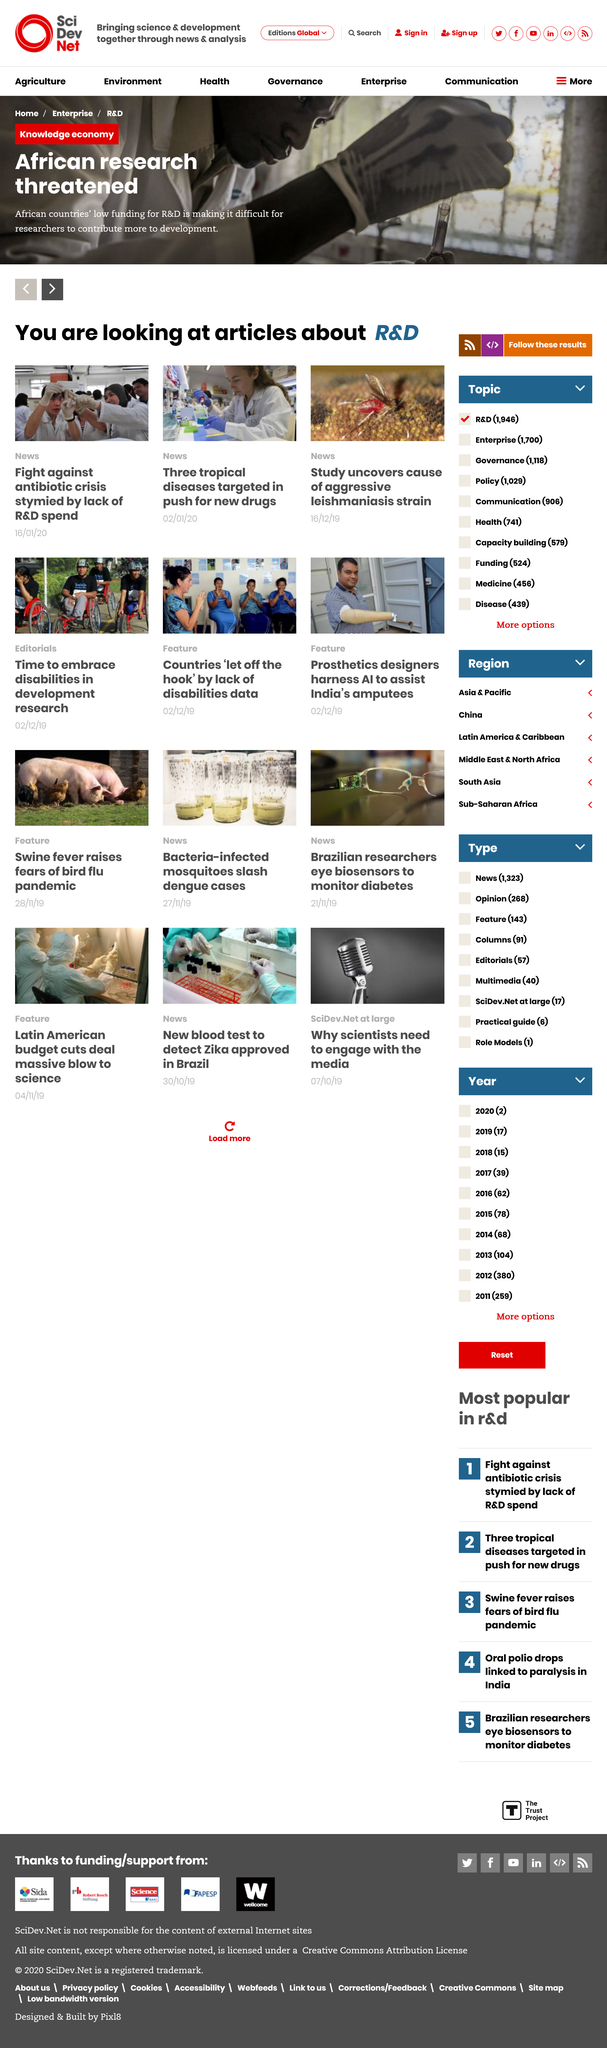Give some essential details in this illustration. The article on three tropical diseases being targeted was published on January 2nd, 2023. The article on a Leishmaniasis strain study was published on December 16, 2019. In a push for new drugs, three tropical diseases were targeted and addressed. 